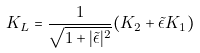<formula> <loc_0><loc_0><loc_500><loc_500>K _ { L } = \frac { 1 } { \sqrt { 1 + | { \tilde { \epsilon } } | ^ { 2 } } } ( K _ { 2 } + \tilde { \epsilon } K _ { 1 } )</formula> 